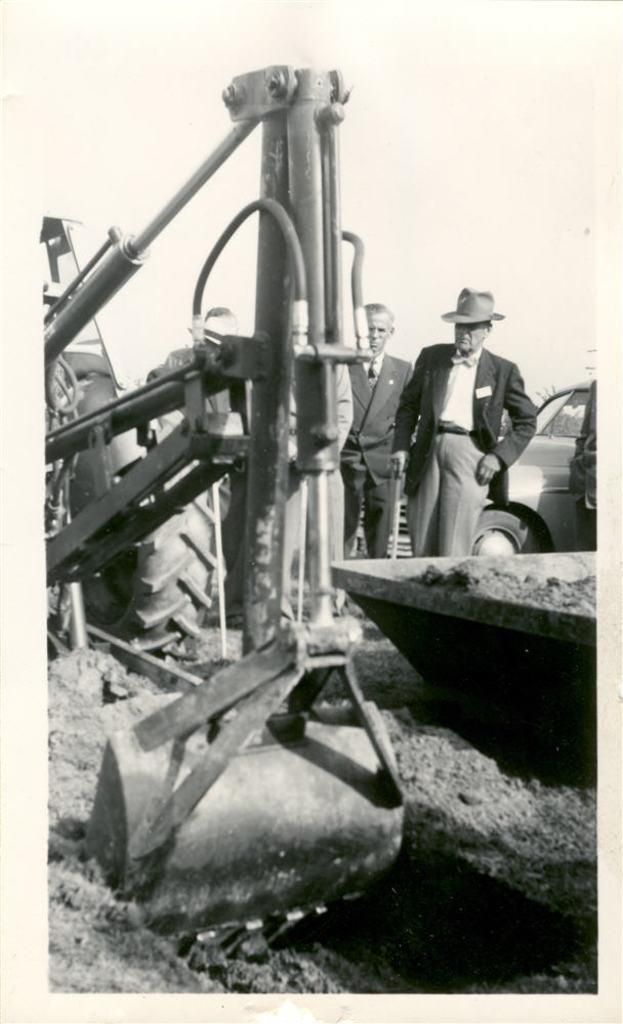What vehicle is located on the left side of the image? There is a tractor on the left side of the image. What can be seen in the background of the image? There are people and a car in the background of the image. Where is the hose located in the image? There is no hose present in the image. How does the car move in the image? The car does not move in the image; it is stationary in the background. 